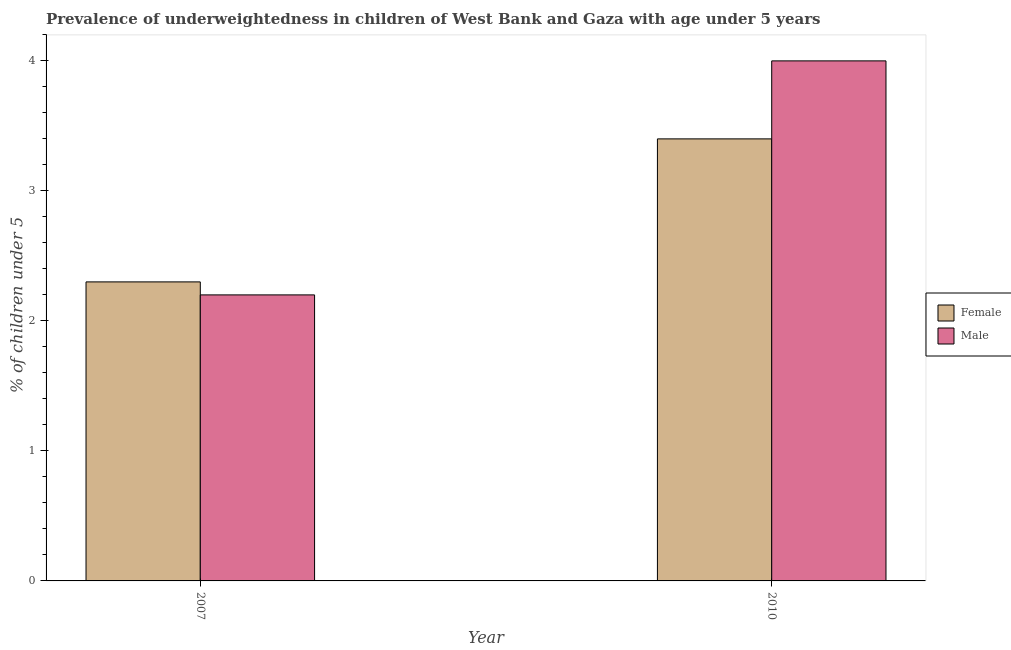In how many cases, is the number of bars for a given year not equal to the number of legend labels?
Ensure brevity in your answer.  0. What is the percentage of underweighted female children in 2010?
Your answer should be compact. 3.4. Across all years, what is the maximum percentage of underweighted male children?
Ensure brevity in your answer.  4. Across all years, what is the minimum percentage of underweighted female children?
Make the answer very short. 2.3. In which year was the percentage of underweighted female children maximum?
Ensure brevity in your answer.  2010. What is the total percentage of underweighted female children in the graph?
Offer a very short reply. 5.7. What is the difference between the percentage of underweighted male children in 2007 and that in 2010?
Give a very brief answer. -1.8. What is the difference between the percentage of underweighted male children in 2010 and the percentage of underweighted female children in 2007?
Your answer should be very brief. 1.8. What is the average percentage of underweighted female children per year?
Your answer should be very brief. 2.85. In how many years, is the percentage of underweighted male children greater than 4 %?
Your response must be concise. 0. What is the ratio of the percentage of underweighted female children in 2007 to that in 2010?
Your response must be concise. 0.68. In how many years, is the percentage of underweighted female children greater than the average percentage of underweighted female children taken over all years?
Offer a very short reply. 1. What does the 2nd bar from the right in 2007 represents?
Make the answer very short. Female. How many years are there in the graph?
Provide a short and direct response. 2. What is the difference between two consecutive major ticks on the Y-axis?
Give a very brief answer. 1. Are the values on the major ticks of Y-axis written in scientific E-notation?
Provide a short and direct response. No. How are the legend labels stacked?
Ensure brevity in your answer.  Vertical. What is the title of the graph?
Offer a terse response. Prevalence of underweightedness in children of West Bank and Gaza with age under 5 years. Does "Methane" appear as one of the legend labels in the graph?
Give a very brief answer. No. What is the label or title of the Y-axis?
Give a very brief answer.  % of children under 5. What is the  % of children under 5 in Female in 2007?
Ensure brevity in your answer.  2.3. What is the  % of children under 5 of Male in 2007?
Offer a terse response. 2.2. What is the  % of children under 5 in Female in 2010?
Offer a terse response. 3.4. Across all years, what is the maximum  % of children under 5 of Female?
Offer a terse response. 3.4. Across all years, what is the minimum  % of children under 5 of Female?
Offer a very short reply. 2.3. Across all years, what is the minimum  % of children under 5 in Male?
Keep it short and to the point. 2.2. What is the total  % of children under 5 in Male in the graph?
Offer a terse response. 6.2. What is the difference between the  % of children under 5 in Female in 2007 and that in 2010?
Ensure brevity in your answer.  -1.1. What is the difference between the  % of children under 5 in Male in 2007 and that in 2010?
Ensure brevity in your answer.  -1.8. What is the average  % of children under 5 in Female per year?
Give a very brief answer. 2.85. What is the average  % of children under 5 in Male per year?
Offer a terse response. 3.1. What is the ratio of the  % of children under 5 in Female in 2007 to that in 2010?
Keep it short and to the point. 0.68. What is the ratio of the  % of children under 5 in Male in 2007 to that in 2010?
Your response must be concise. 0.55. What is the difference between the highest and the second highest  % of children under 5 in Male?
Offer a terse response. 1.8. 